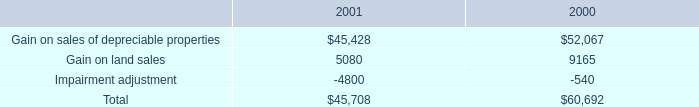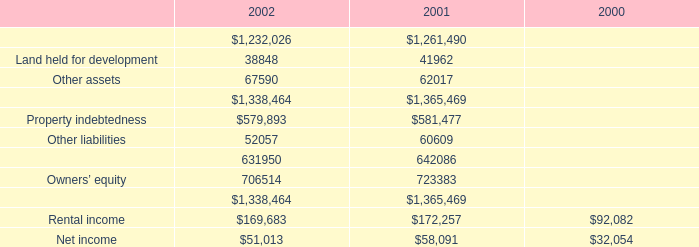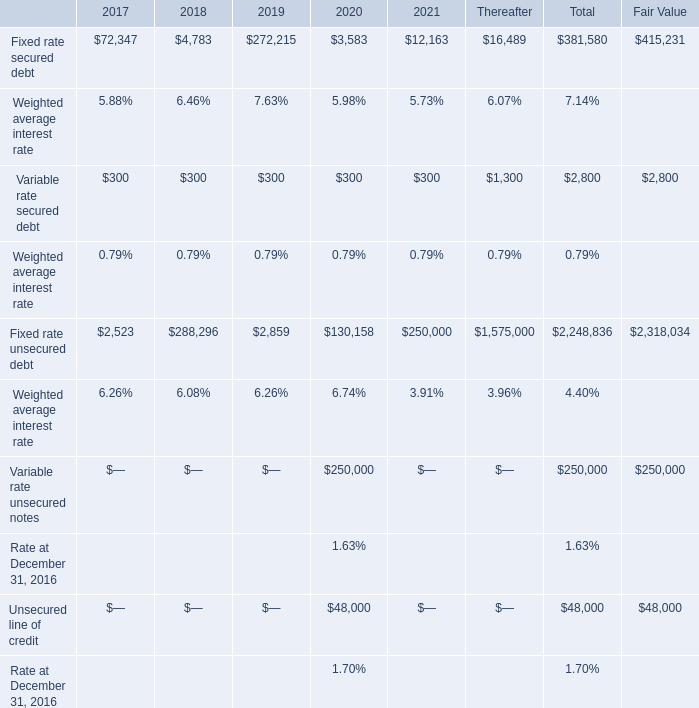If Fixed rate secured debt develops with the same growth rate in 2021, what will it reach in 2022?" (in million) 
Computations: ((1 + ((12163 - 3583) / 3583)) * 12163)
Answer: 41289.02289. 